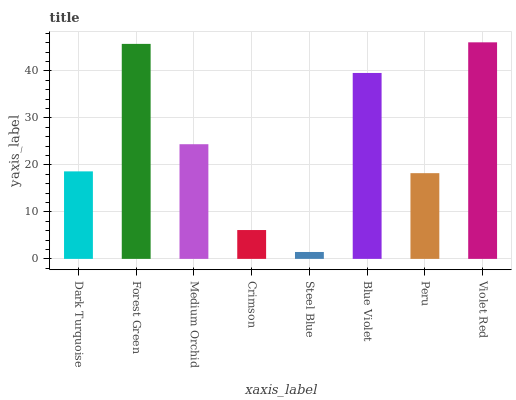Is Steel Blue the minimum?
Answer yes or no. Yes. Is Violet Red the maximum?
Answer yes or no. Yes. Is Forest Green the minimum?
Answer yes or no. No. Is Forest Green the maximum?
Answer yes or no. No. Is Forest Green greater than Dark Turquoise?
Answer yes or no. Yes. Is Dark Turquoise less than Forest Green?
Answer yes or no. Yes. Is Dark Turquoise greater than Forest Green?
Answer yes or no. No. Is Forest Green less than Dark Turquoise?
Answer yes or no. No. Is Medium Orchid the high median?
Answer yes or no. Yes. Is Dark Turquoise the low median?
Answer yes or no. Yes. Is Blue Violet the high median?
Answer yes or no. No. Is Forest Green the low median?
Answer yes or no. No. 